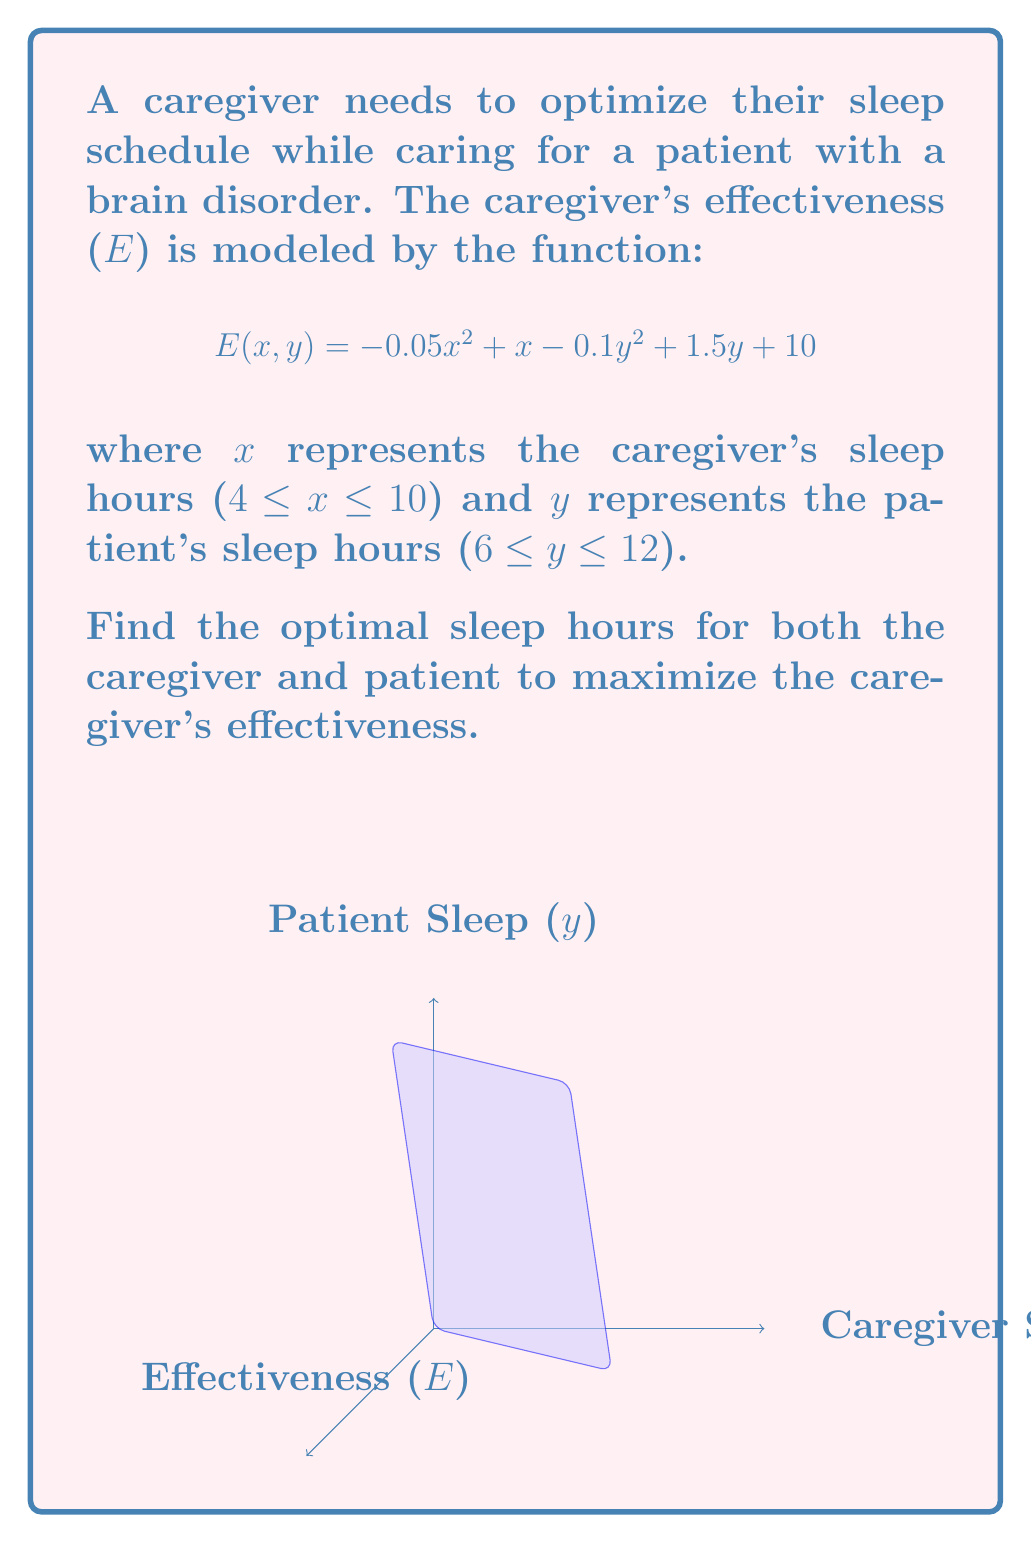Solve this math problem. To find the optimal sleep hours, we need to maximize the function $E(x, y)$. This is a constrained optimization problem, so we'll use the following steps:

1) Find the critical points by taking partial derivatives and setting them to zero:

   $\frac{\partial E}{\partial x} = -0.1x + 1 = 0$
   $\frac{\partial E}{\partial y} = -0.2y + 1.5 = 0$

2) Solve these equations:
   
   $x = 10$ hours
   $y = 7.5$ hours

3) Check if these points are within the given constraints:
   
   For x: 4 ≤ 10 ≤ 10 (satisfies the constraint)
   For y: 6 ≤ 7.5 ≤ 12 (satisfies the constraint)

4) Check the boundaries of the constraints:

   At x = 4: $\frac{\partial E}{\partial x} = -0.1(4) + 1 = 0.6 > 0$, so E increases as x increases from 4.
   At x = 10: $\frac{\partial E}{\partial x} = -0.1(10) + 1 = 0$, confirming the critical point.

   At y = 6: $\frac{\partial E}{\partial y} = -0.2(6) + 1.5 = 0.3 > 0$, so E increases as y increases from 6.
   At y = 12: $\frac{\partial E}{\partial y} = -0.2(12) + 1.5 = -0.9 < 0$, so E decreases as y approaches 12.

5) Evaluate the second partial derivatives to confirm it's a maximum:

   $\frac{\partial^2 E}{\partial x^2} = -0.1 < 0$
   $\frac{\partial^2 E}{\partial y^2} = -0.2 < 0$

   This confirms that (10, 7.5) is indeed a local maximum within the given constraints.

Therefore, the optimal sleep schedule is 10 hours for the caregiver and 7.5 hours for the patient.
Answer: Caregiver: 10 hours; Patient: 7.5 hours 